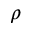<formula> <loc_0><loc_0><loc_500><loc_500>\rho</formula> 